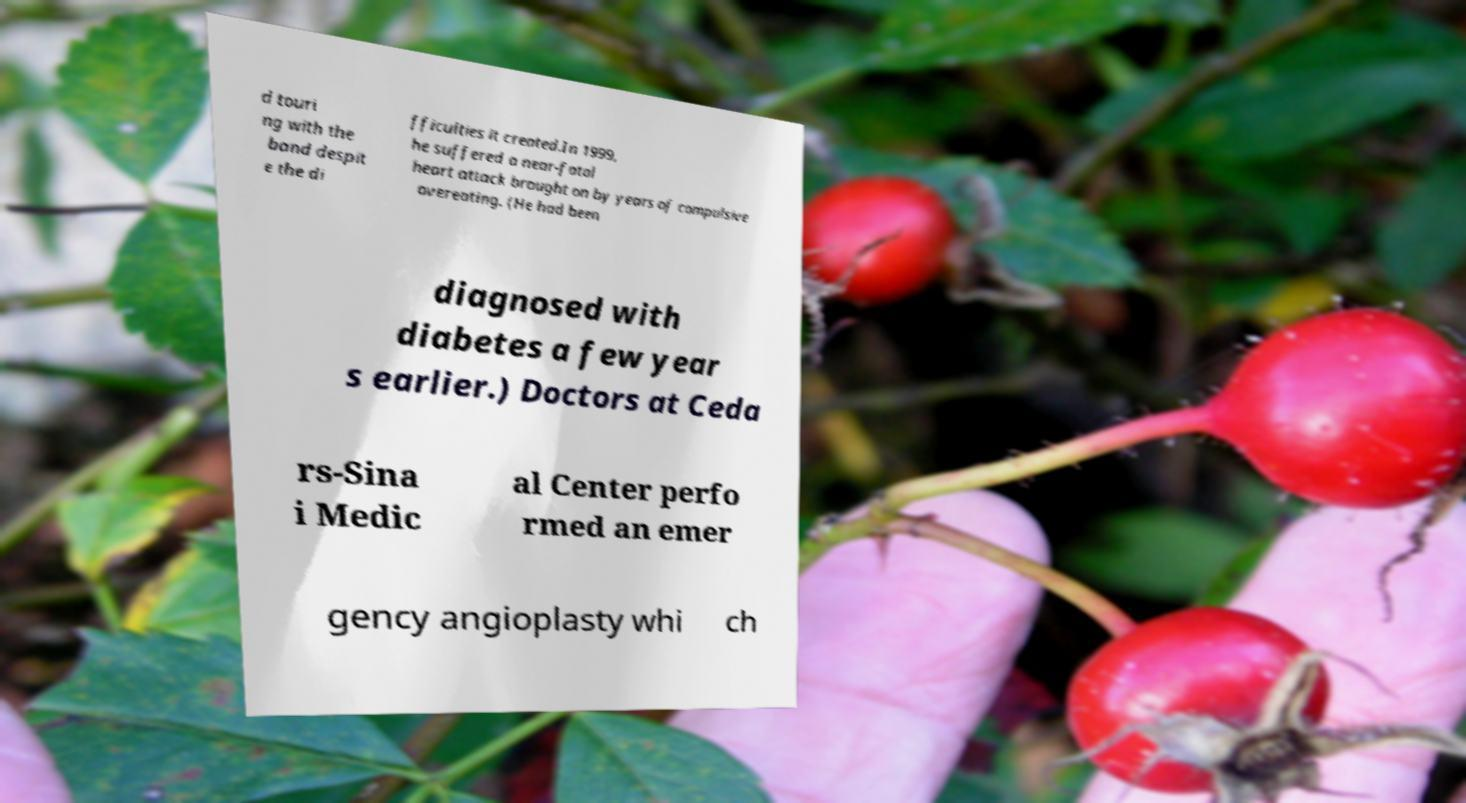I need the written content from this picture converted into text. Can you do that? d touri ng with the band despit e the di fficulties it created.In 1999, he suffered a near-fatal heart attack brought on by years of compulsive overeating. (He had been diagnosed with diabetes a few year s earlier.) Doctors at Ceda rs-Sina i Medic al Center perfo rmed an emer gency angioplasty whi ch 